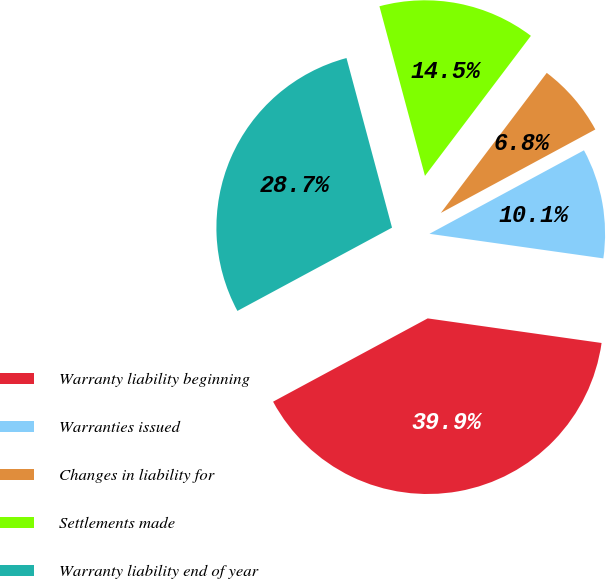Convert chart. <chart><loc_0><loc_0><loc_500><loc_500><pie_chart><fcel>Warranty liability beginning<fcel>Warranties issued<fcel>Changes in liability for<fcel>Settlements made<fcel>Warranty liability end of year<nl><fcel>39.9%<fcel>10.12%<fcel>6.81%<fcel>14.48%<fcel>28.69%<nl></chart> 